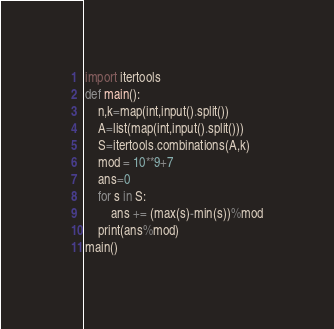<code> <loc_0><loc_0><loc_500><loc_500><_Python_>import itertools
def main():
    n,k=map(int,input().split())
    A=list(map(int,input().split()))
    S=itertools.combinations(A,k)
    mod = 10**9+7
    ans=0
    for s in S:
        ans += (max(s)-min(s))%mod
    print(ans%mod)
main()</code> 